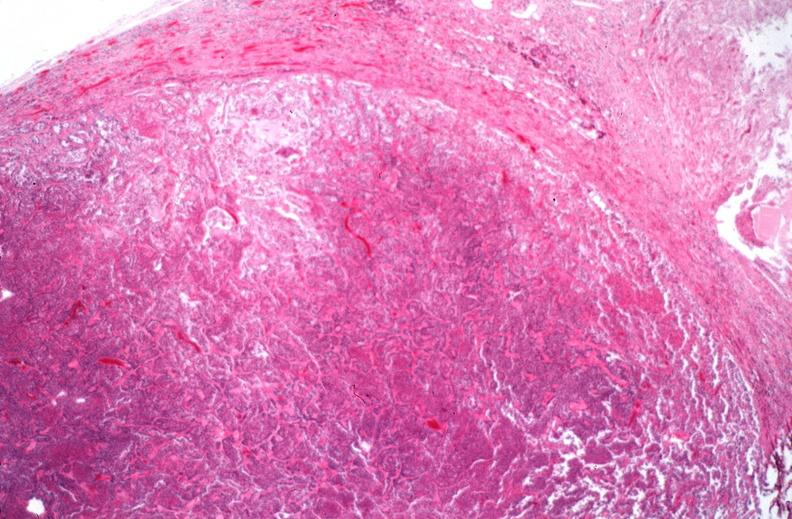does this section showing liver with tumor mass in hilar area tumor show pituitary, chromaphobe adenoma?
Answer the question using a single word or phrase. No 